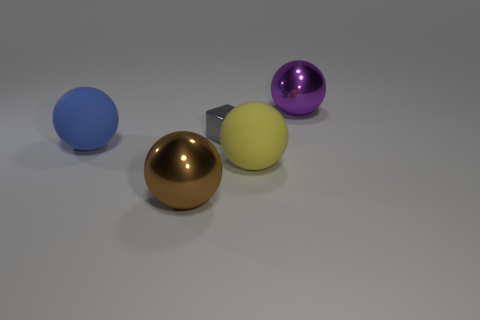If this image represented a solar system, which object would most likely be the sun based on size and position? If this arrangement were to mimic a solar system, the large blue sphere, given its size and central position, would be suggestive of the sun. The gold and purple spheres, being smaller and positioned further out, could represent planets orbiting the central 'sun,' while the yellow cube may serve as a smaller body, like a dwarf planet or moon within this celestial system. 